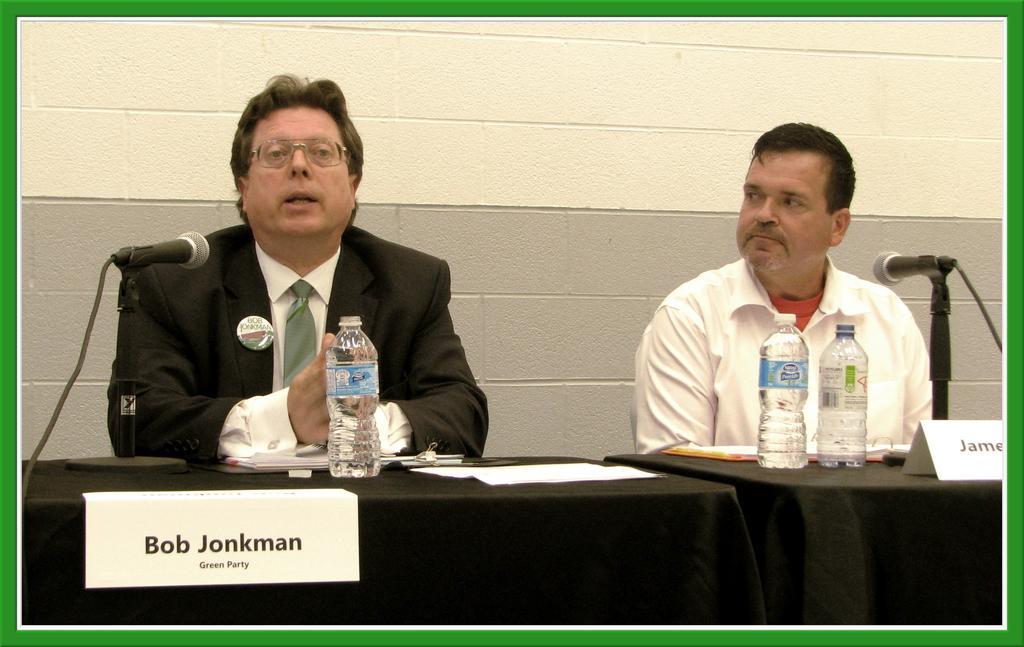Can you describe this image briefly? In this picture we can see two men and a man wore spectacles, blazer, tie and in front of them we can see bottles, papers, name boards, mics, black clothes on tables and in the background we can see the wall. 